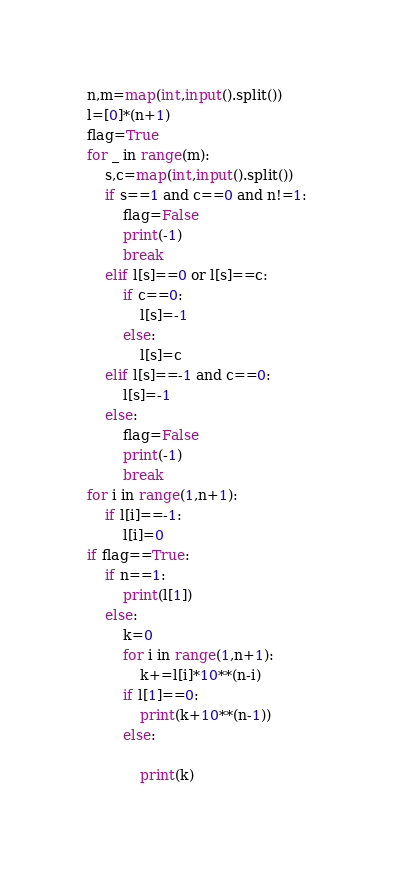<code> <loc_0><loc_0><loc_500><loc_500><_Python_>n,m=map(int,input().split())
l=[0]*(n+1)
flag=True
for _ in range(m):
    s,c=map(int,input().split())
    if s==1 and c==0 and n!=1:
        flag=False
        print(-1)
        break
    elif l[s]==0 or l[s]==c:
        if c==0:
            l[s]=-1
        else:
            l[s]=c
    elif l[s]==-1 and c==0:
        l[s]=-1
    else:
        flag=False
        print(-1)
        break
for i in range(1,n+1):
    if l[i]==-1:
        l[i]=0
if flag==True:
    if n==1:
        print(l[1])
    else:
        k=0
        for i in range(1,n+1):
            k+=l[i]*10**(n-i)
        if l[1]==0:
            print(k+10**(n-1))
        else:
            
            print(k)</code> 